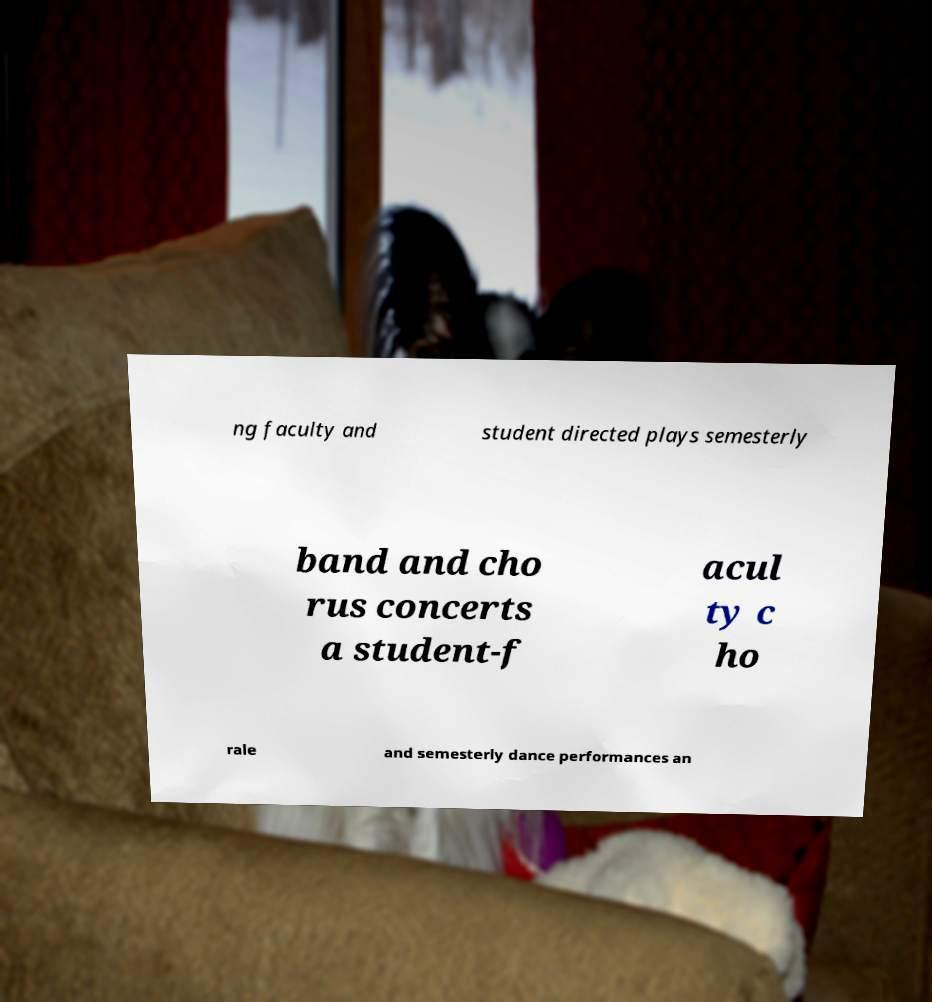Could you extract and type out the text from this image? ng faculty and student directed plays semesterly band and cho rus concerts a student-f acul ty c ho rale and semesterly dance performances an 